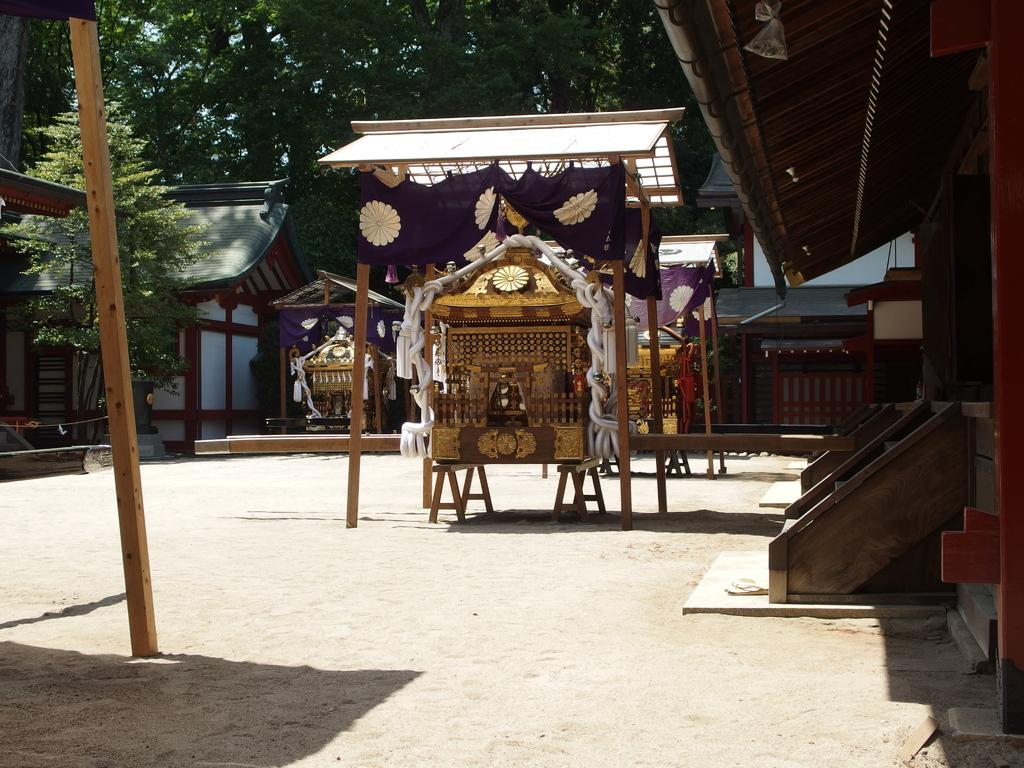What is the main subject in the middle of the image? There are palanquins in the middle of the image. What can be seen in the background of the image? There are houses and trees in the background of the image. What architectural feature is present on the right side of the image? There are wooden staircases on the right side of the image. What type of soup is being served in the image? There is no soup present in the image. What territory is being claimed by the palanquins in the image? The image does not depict any territorial claims or disputes; it simply shows palanquins in the middle of the image. 